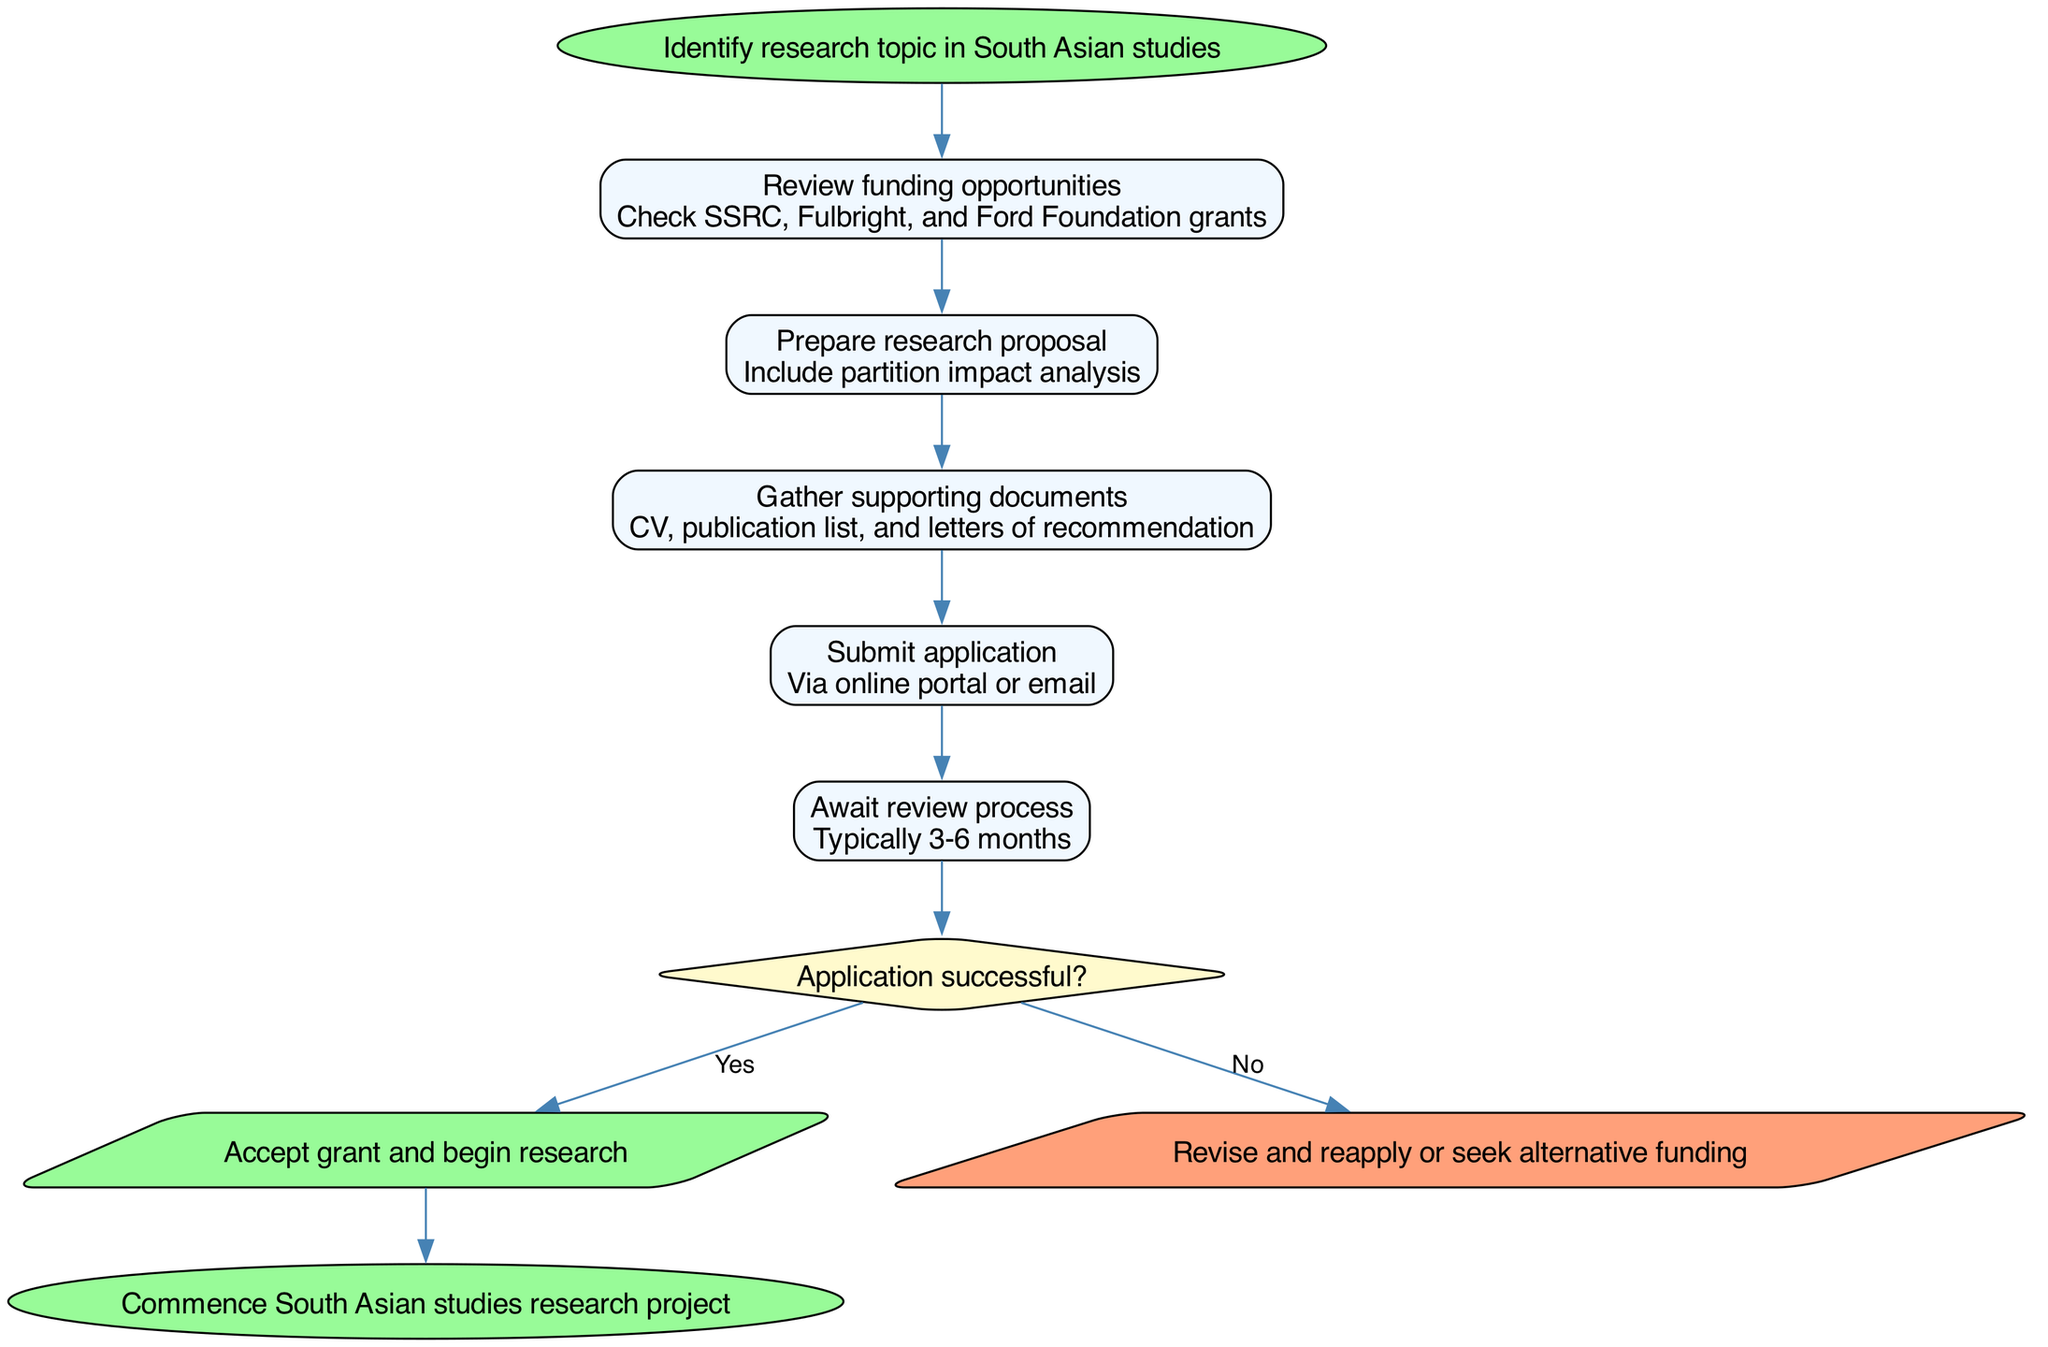What is the first step in the grant application process? The first step is to "Identify research topic in South Asian studies," as indicated by the start node in the flow chart.
Answer: Identify research topic in South Asian studies How many steps are there in the process? The flow chart lists five specific steps that involve various actions before the decision point, indicating the total count.
Answer: Five steps What document is required to be submitted along with the application? The flow chart specifies that "CV, publication list, and letters of recommendation" are required as supporting documents, indicating their importance in the application process.
Answer: CV, publication list, and letters of recommendation What happens if the application is successful? According to the decision node, if the application is successful, the next action is to "Accept grant and begin research." This provides a clear outcome for success in the grant application process.
Answer: Accept grant and begin research What is the typical duration of the review process? The flow chart provides a clear timeframe of "Typically 3-6 months" for the review process, giving a specific range for how long applicants may need to wait after submission.
Answer: Typically 3-6 months What are the two possible outcomes after the review? The decision node presents two outcomes: "Accept grant and begin research" if successful, or "Revise and reapply or seek alternative funding" if unsuccessful. This reflects the options available based on the application result.
Answer: Accept grant and begin research; Revise and reapply or seek alternative funding Which node follows the "Gather supporting documents"? The flow chart indicates that after "Gathering supporting documents," the next step is to "Submit application." This reflects the sequential nature of the process.
Answer: Submit application What shape represents the decision points in the diagram? The flow chart uses a diamond shape to represent decision points, which is standard in flow diagrams to indicate a branching decision based on the outcome.
Answer: Diamond shape What is the final action in the grant application process? The flow chart concludes with the action "Commence South Asian studies research project," marking the conclusion of the grant application process if successful.
Answer: Commence South Asian studies research project 